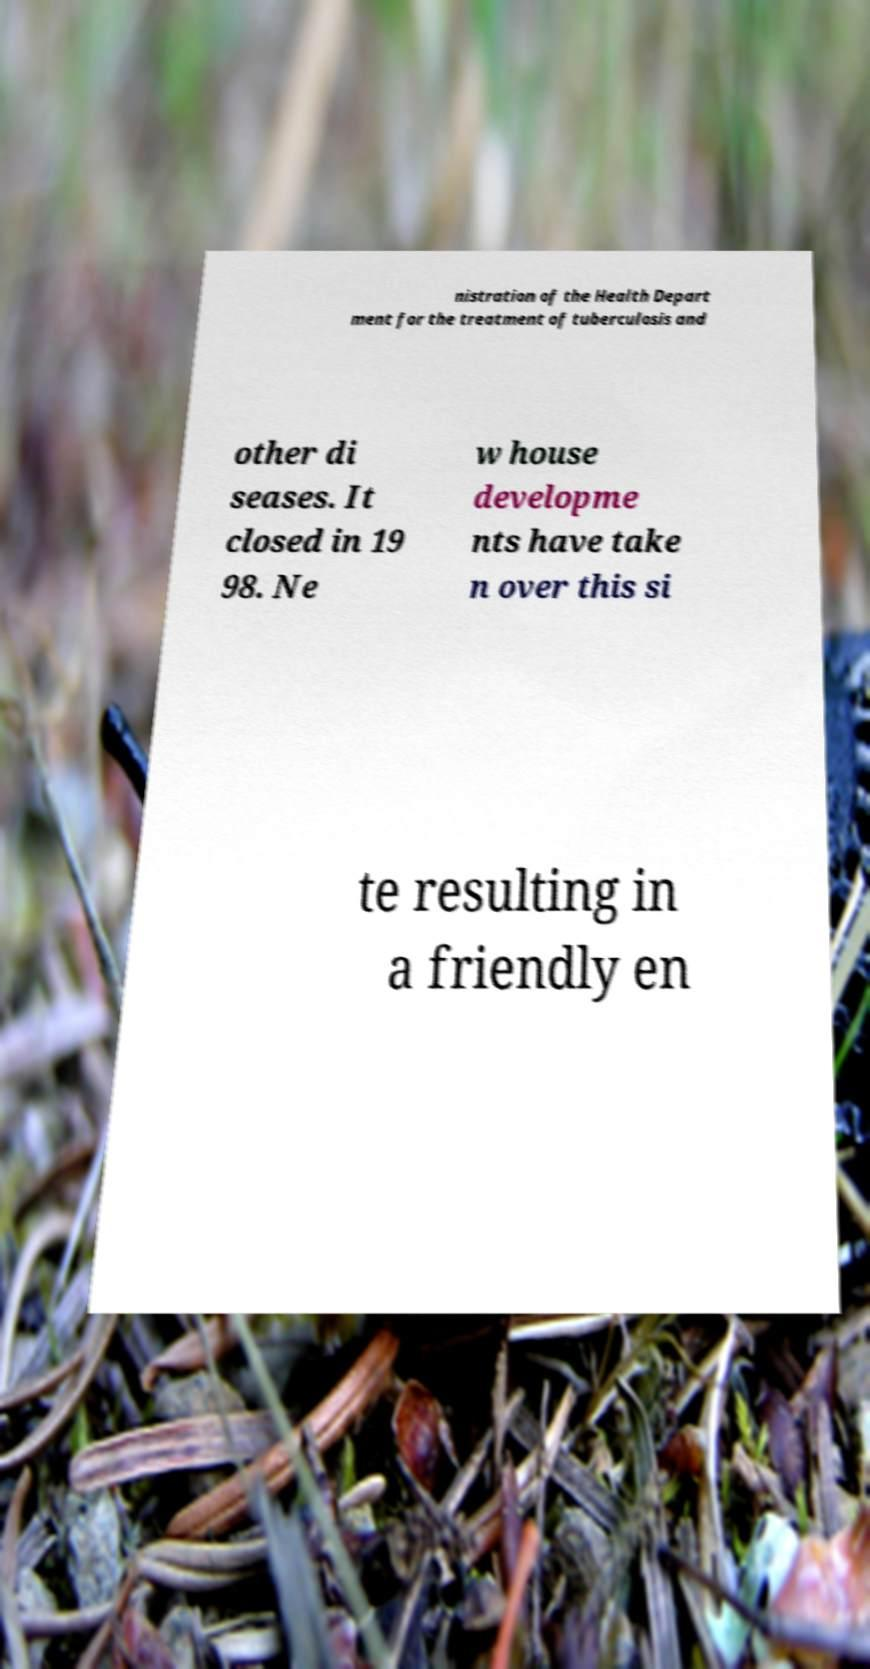What messages or text are displayed in this image? I need them in a readable, typed format. nistration of the Health Depart ment for the treatment of tuberculosis and other di seases. It closed in 19 98. Ne w house developme nts have take n over this si te resulting in a friendly en 